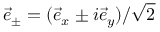Convert formula to latex. <formula><loc_0><loc_0><loc_500><loc_500>\vec { e } _ { \pm } = ( \vec { e } _ { x } \pm i \vec { e } _ { y } ) / \sqrt { 2 }</formula> 